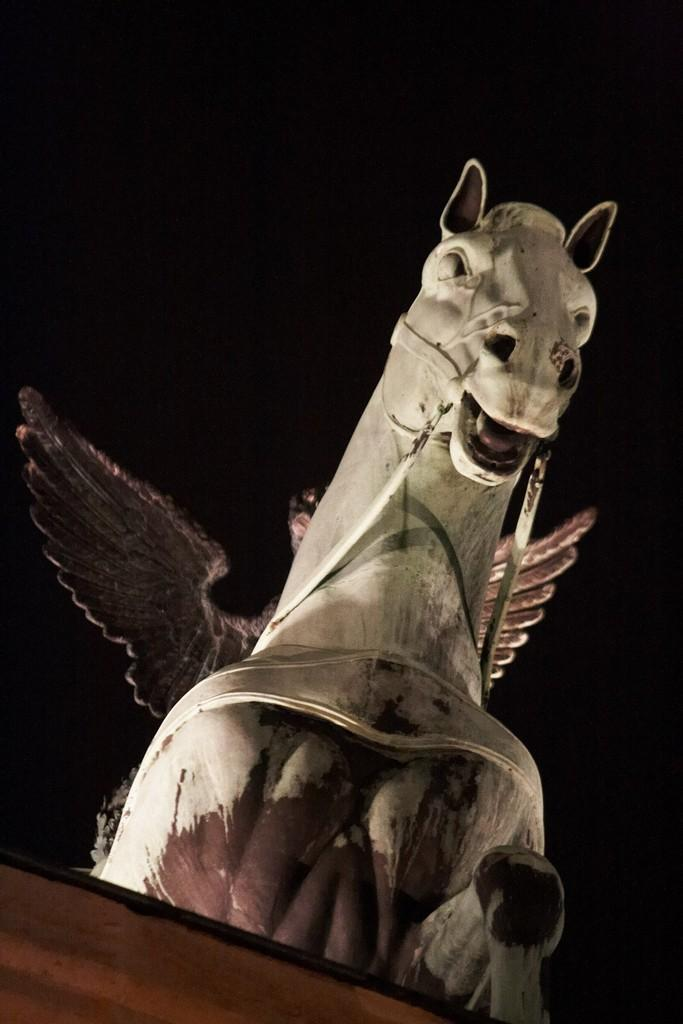What is the main subject of the image? The main subject of the image is a horse statue. What distinguishing feature does the horse statue have? The horse statue has wings. How many apples are on the ground near the horse statue in the image? There is no mention of apples in the image, so we cannot determine how many apples are present. 